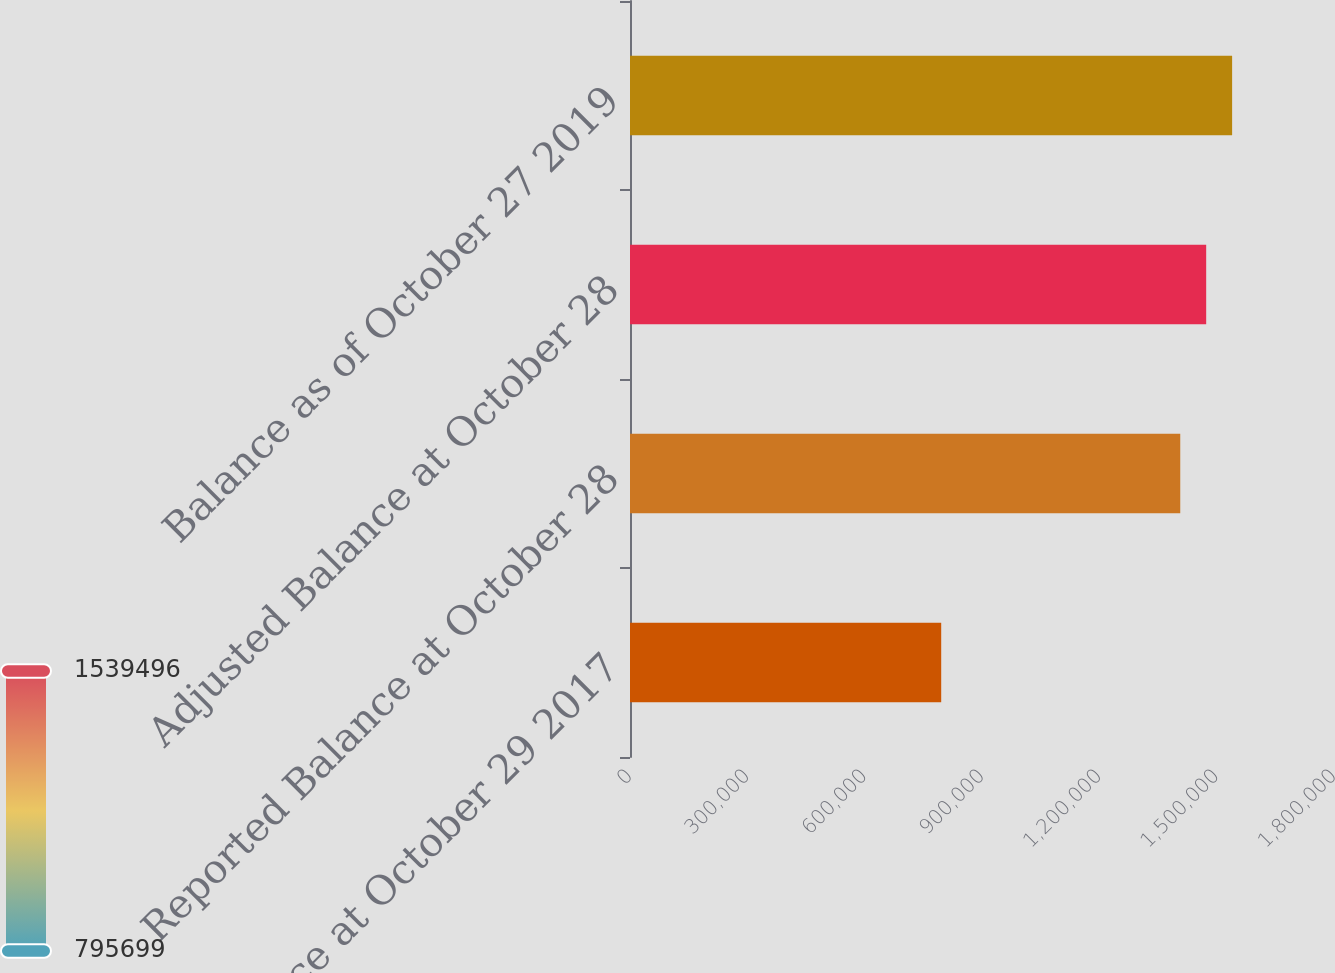Convert chart. <chart><loc_0><loc_0><loc_500><loc_500><bar_chart><fcel>Balance at October 29 2017<fcel>Reported Balance at October 28<fcel>Adjusted Balance at October 28<fcel>Balance as of October 27 2019<nl><fcel>795699<fcel>1.4069e+06<fcel>1.4732e+06<fcel>1.5395e+06<nl></chart> 